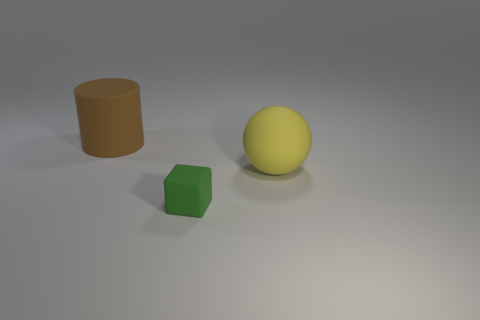Add 3 green matte cubes. How many objects exist? 6 Subtract 1 balls. How many balls are left? 0 Subtract all cylinders. How many objects are left? 2 Subtract all red balls. Subtract all gray cylinders. How many balls are left? 1 Subtract all purple blocks. How many red cylinders are left? 0 Subtract all small cyan rubber balls. Subtract all green objects. How many objects are left? 2 Add 2 big matte balls. How many big matte balls are left? 3 Add 3 balls. How many balls exist? 4 Subtract 0 green spheres. How many objects are left? 3 